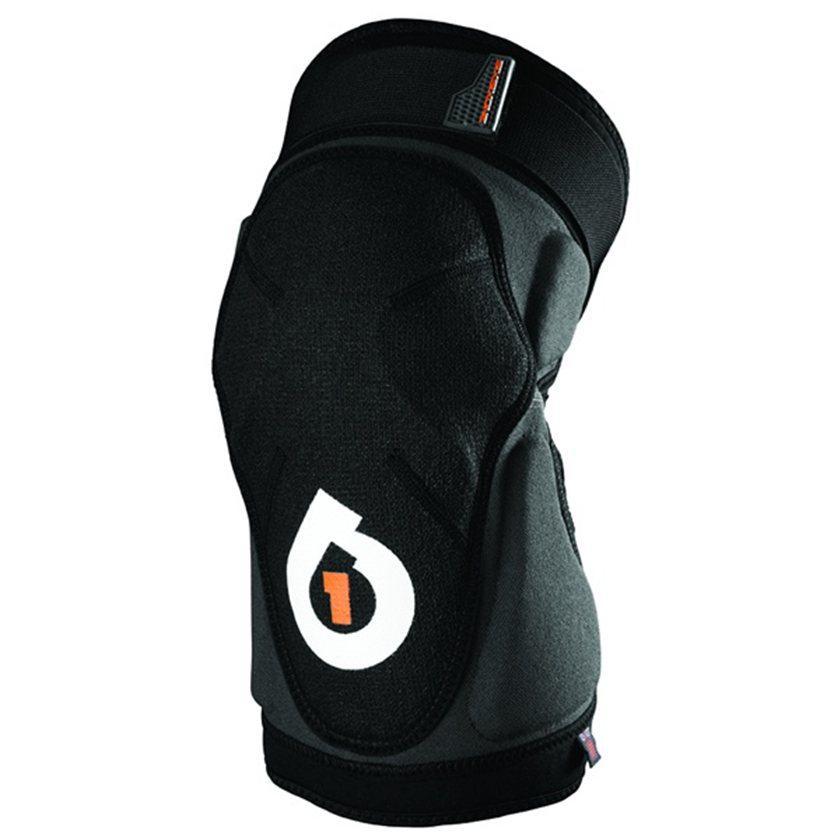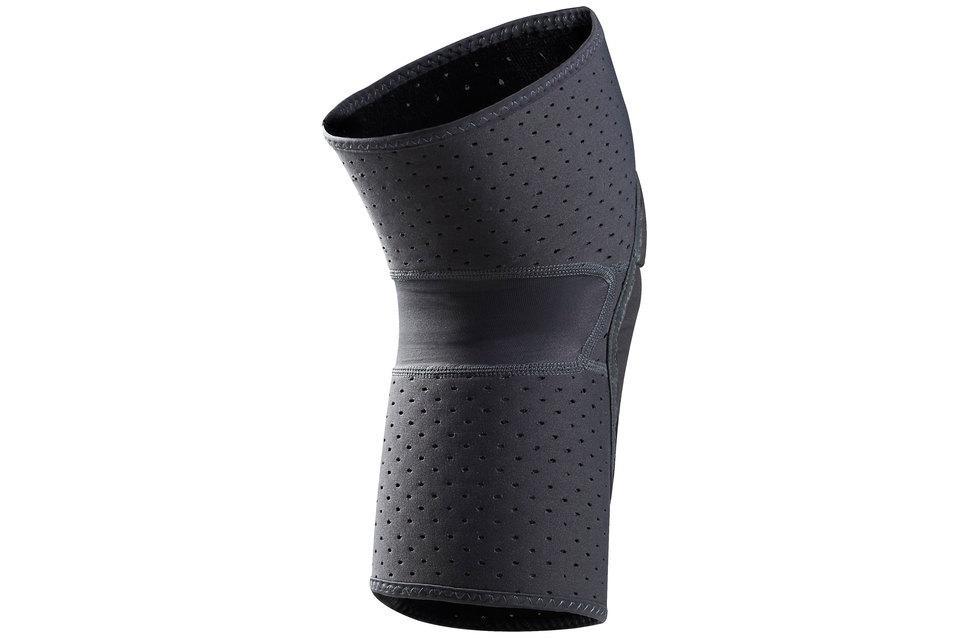The first image is the image on the left, the second image is the image on the right. For the images displayed, is the sentence "One image shows what the back side of the knee pad looks like." factually correct? Answer yes or no. Yes. The first image is the image on the left, the second image is the image on the right. Evaluate the accuracy of this statement regarding the images: "All of the images contain only one knee guard.". Is it true? Answer yes or no. Yes. 